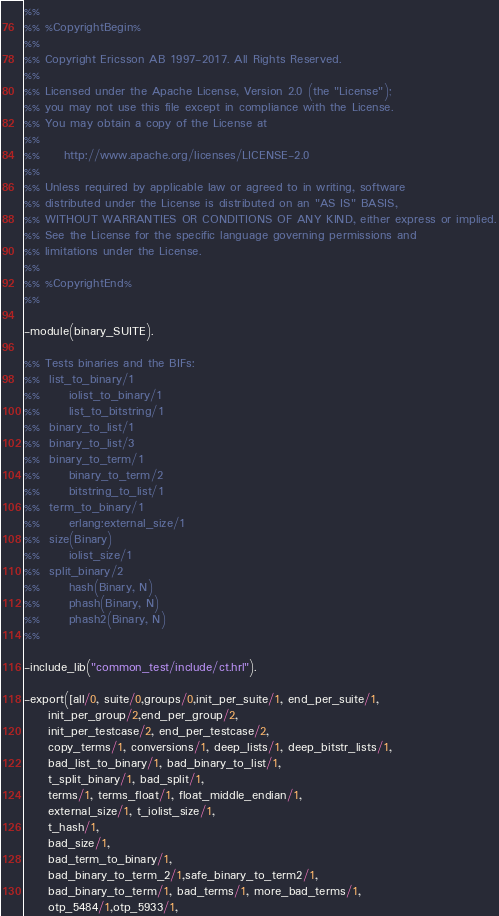Convert code to text. <code><loc_0><loc_0><loc_500><loc_500><_Erlang_>%%
%% %CopyrightBegin%
%%
%% Copyright Ericsson AB 1997-2017. All Rights Reserved.
%%
%% Licensed under the Apache License, Version 2.0 (the "License");
%% you may not use this file except in compliance with the License.
%% You may obtain a copy of the License at
%%
%%     http://www.apache.org/licenses/LICENSE-2.0
%%
%% Unless required by applicable law or agreed to in writing, software
%% distributed under the License is distributed on an "AS IS" BASIS,
%% WITHOUT WARRANTIES OR CONDITIONS OF ANY KIND, either express or implied.
%% See the License for the specific language governing permissions and
%% limitations under the License.
%%
%% %CopyrightEnd%
%%

-module(binary_SUITE).

%% Tests binaries and the BIFs:
%%	list_to_binary/1
%%      iolist_to_binary/1
%%      list_to_bitstring/1
%%	binary_to_list/1
%%	binary_to_list/3
%%	binary_to_term/1
%%  	binary_to_term/2
%%      bitstring_to_list/1
%%	term_to_binary/1
%%      erlang:external_size/1
%%	size(Binary)
%%      iolist_size/1
%%	split_binary/2
%%      hash(Binary, N)
%%      phash(Binary, N)
%%      phash2(Binary, N)
%%

-include_lib("common_test/include/ct.hrl").

-export([all/0, suite/0,groups/0,init_per_suite/1, end_per_suite/1, 
	 init_per_group/2,end_per_group/2, 
	 init_per_testcase/2, end_per_testcase/2,
	 copy_terms/1, conversions/1, deep_lists/1, deep_bitstr_lists/1,
	 bad_list_to_binary/1, bad_binary_to_list/1,
	 t_split_binary/1, bad_split/1,
	 terms/1, terms_float/1, float_middle_endian/1,
	 external_size/1, t_iolist_size/1,
	 t_hash/1,
	 bad_size/1,
	 bad_term_to_binary/1,
	 bad_binary_to_term_2/1,safe_binary_to_term2/1,
	 bad_binary_to_term/1, bad_terms/1, more_bad_terms/1,
	 otp_5484/1,otp_5933/1,</code> 